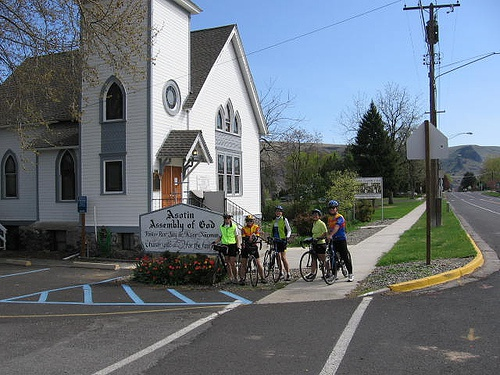Describe the objects in this image and their specific colors. I can see people in black, maroon, navy, and gray tones, people in black, maroon, gray, and olive tones, people in black, gray, and darkgreen tones, people in black, gray, lightgreen, and green tones, and people in black, darkgreen, gray, and darkgray tones in this image. 